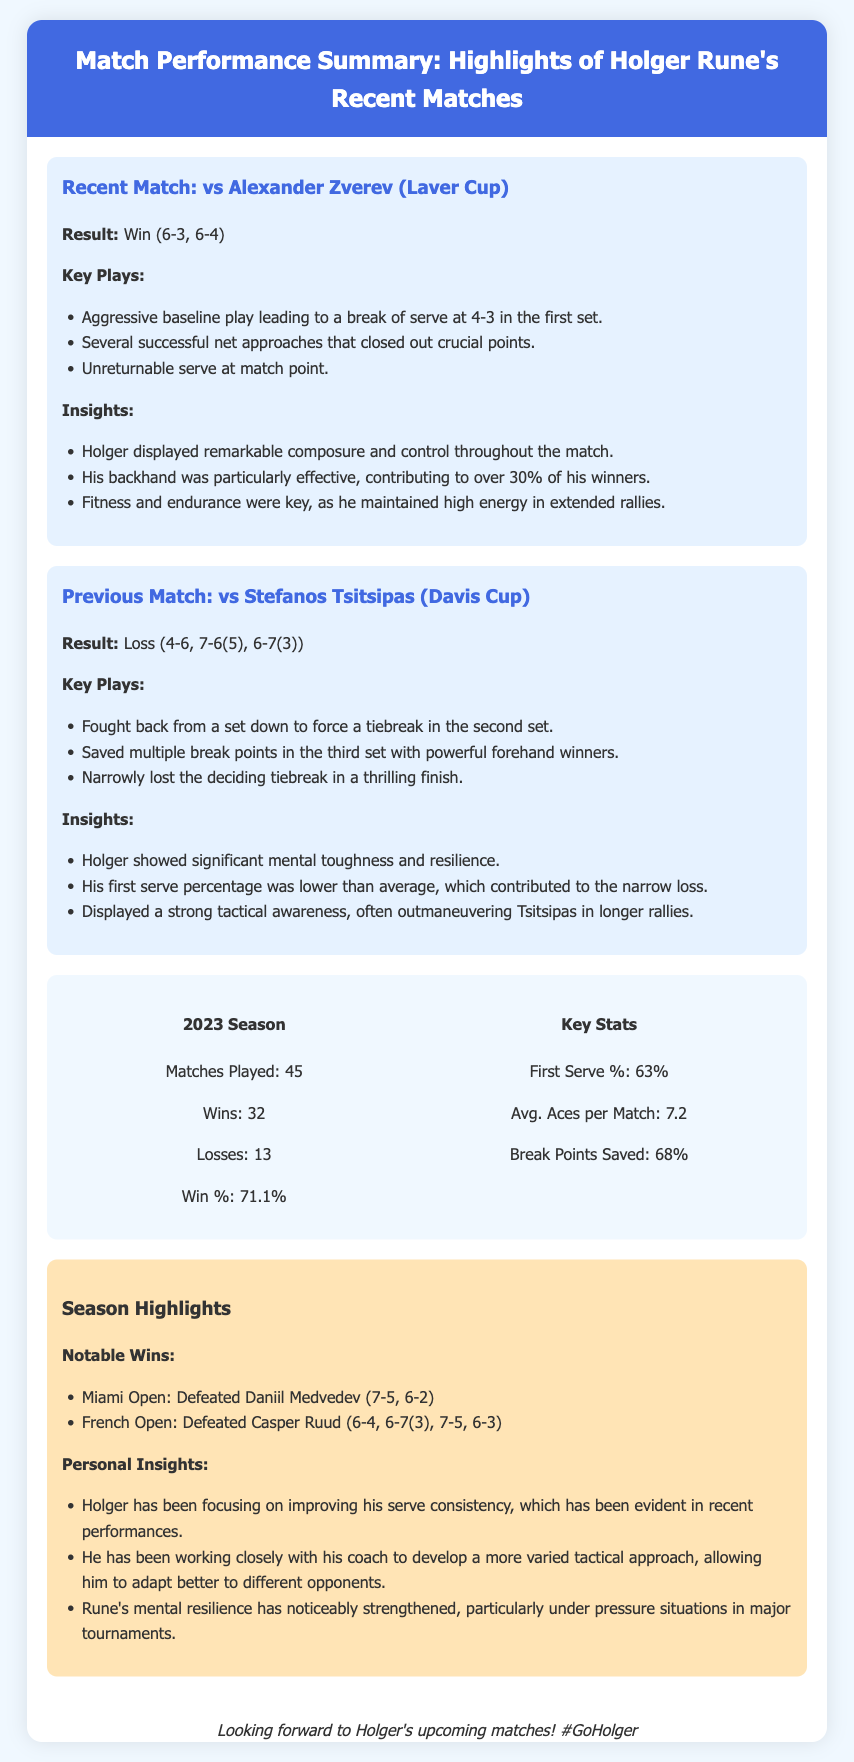What was the result of Holger's recent match against Alexander Zverev? The result is stated in the document as a win with specific set scores.
Answer: Win (6-3, 6-4) How many matches has Holger played in the 2023 season? The total number of matches played is listed in the stats section of the document.
Answer: 45 What percentage of first serves did Holger achieve in 2023? The document provides specific stats that include the first serve percentage.
Answer: 63% Who did Holger defeat at the Miami Open? The document lists notable wins, including the specific opponent at the Miami Open.
Answer: Daniil Medvedev What insight is provided about Holger's backhand performance in his match against Zverev? The insight highlights a specific aspect of his performance during that match.
Answer: It was particularly effective, contributing to over 30% of his winners How many total wins does Holger have in the 2023 season? The total number of wins is detailed in the statistics section of the document.
Answer: 32 What match did Holger lose that was part of the Davis Cup? The previous match result is mentioned, specifying the opponent in the Davis Cup.
Answer: vs Stefanos Tsitsipas What key tactical improvement has Holger been focusing on? The document lists specific personal insights about Holger's current focus areas.
Answer: Serve consistency What notable match format did Holger encounter in his loss to Tsitsipas? The document specifies that the match format included specific set types.
Answer: Tiebreak 